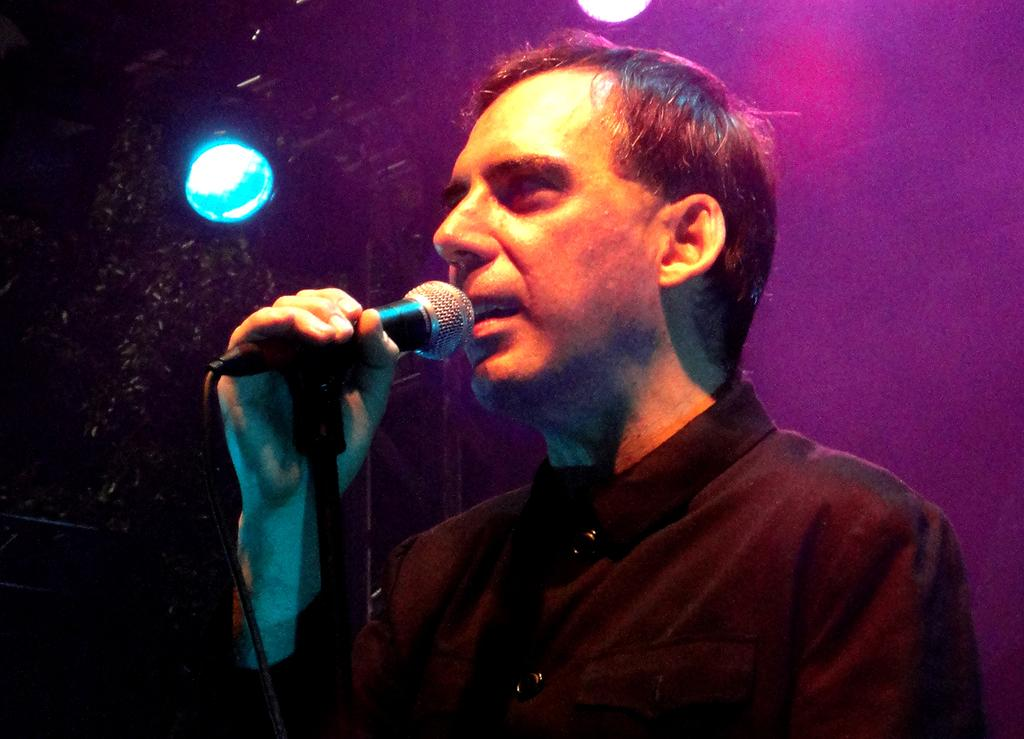Who is the main subject in the image? There is a man in the image. What is the man holding in the image? The man is holding a microphone. What is the man doing in the image? The man is singing. What type of light can be seen in the image? There is no specific light source mentioned in the image, so it cannot be determined what type of light is present. 